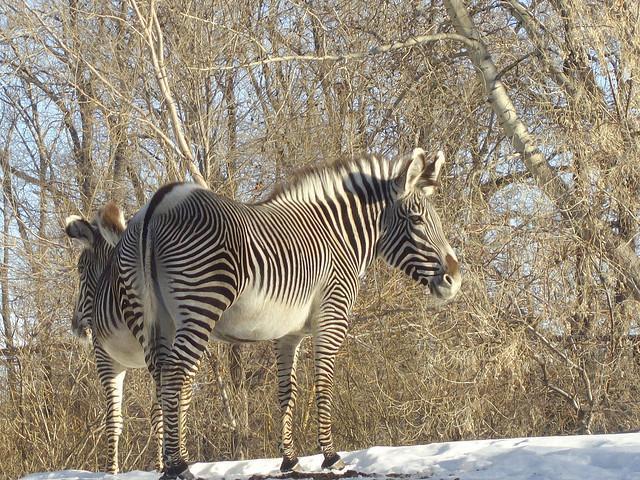How many zebras are there in this picture?
Give a very brief answer. 2. How many zebras are not standing?
Give a very brief answer. 0. How many zebras are there?
Give a very brief answer. 2. How many zebras can you see?
Give a very brief answer. 2. 